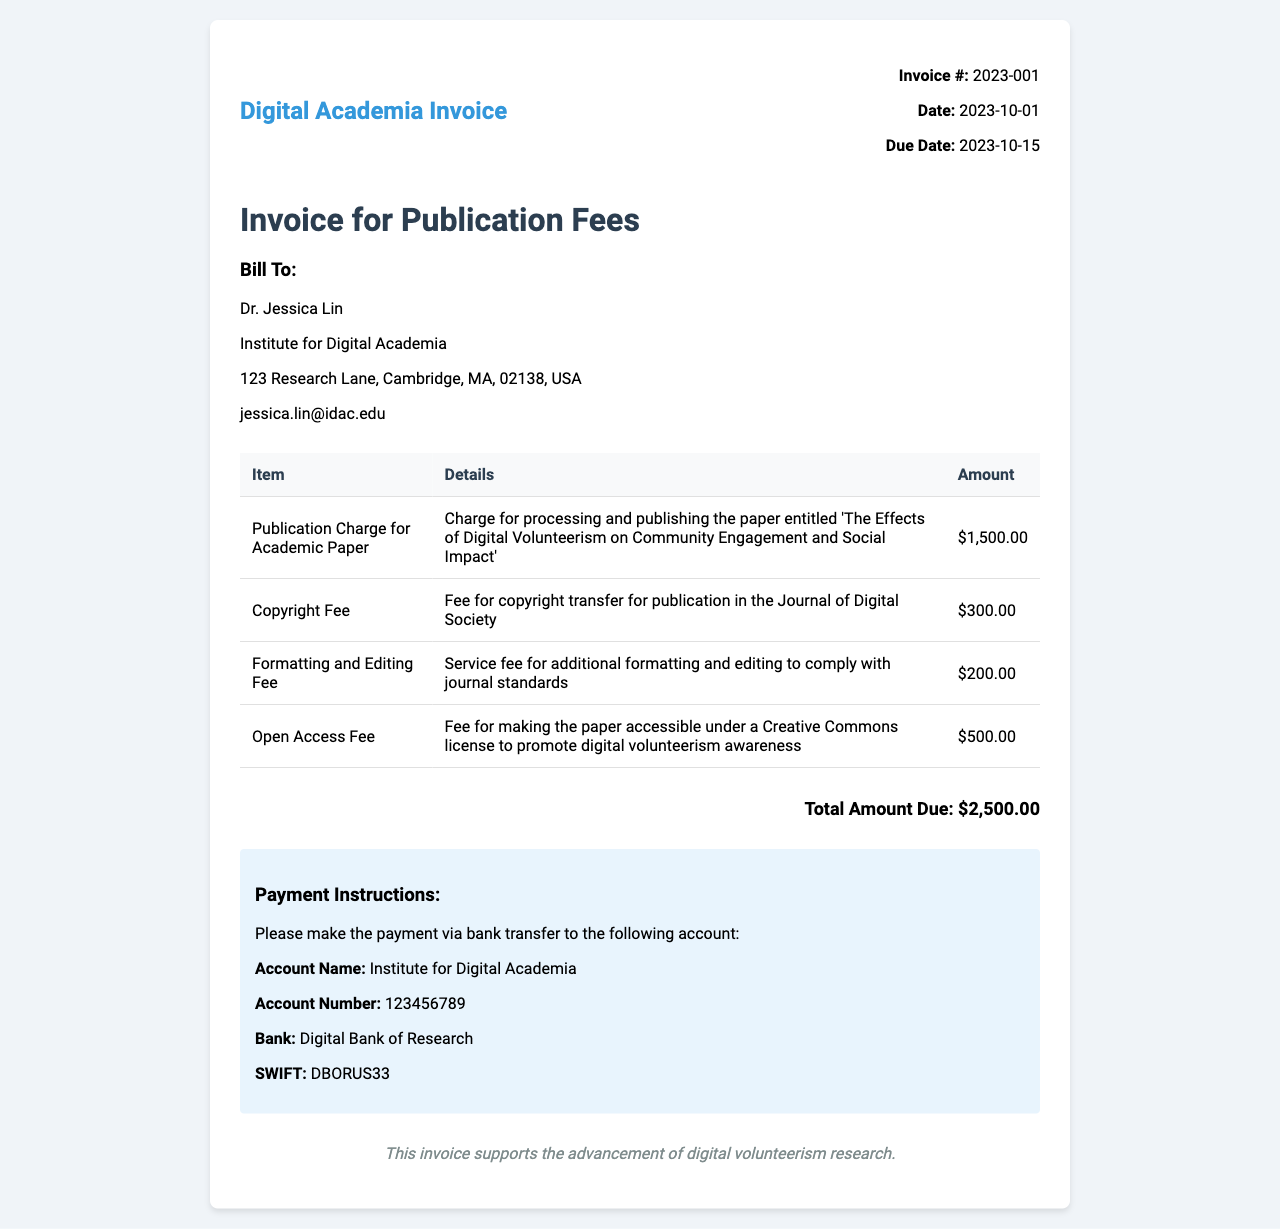What is the invoice number? The invoice number is a unique identifier for the invoice, found in the invoice details section.
Answer: 2023-001 What is the total amount due? The total amount due is the sum of all fees listed in the invoice, clearly stated at the bottom of the document.
Answer: $2,500.00 Who is the bill to? This refers to the recipient of the invoice, mentioned in the bill to section.
Answer: Dr. Jessica Lin What is the due date for payment? The due date indicates when the payment must be completed, as listed in the invoice details.
Answer: 2023-10-15 What is the copyright fee? This fee refers to the charge related to copyright transfer, explicitly mentioned in the itemized list.
Answer: $300.00 What is the publication charge for? This describes the primary fee associated with the processing and publishing of the academic paper.
Answer: Charge for processing and publishing the paper entitled 'The Effects of Digital Volunteerism on Community Engagement and Social Impact' What is the purpose of the Open Access Fee? This fee is specifically related to making the paper accessible under a particular license to promote a cause.
Answer: To promote digital volunteerism awareness What bank should the payment be made to? The bank listed is where the payment should be transferred as instructed in the payment instructions section.
Answer: Digital Bank of Research What is the date of the invoice? This indicates when the invoice was issued, which is crucial for payment timelines.
Answer: 2023-10-01 